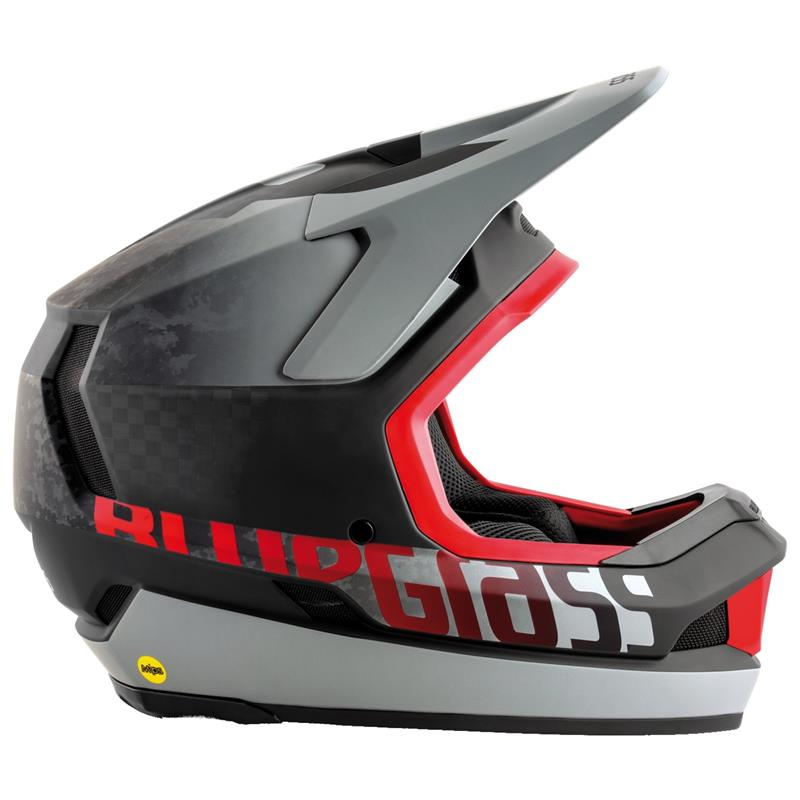Considering the design and features of this helmet, what specific safety standards or certifications does the yellow sticker on the lower left side of the helmet represent, and why might this be important for a user? The yellow sticker on the lower left side of the helmet likely represents a specific safety certification, which is crucial for ensuring the helmet's reliability and protective performance. Although the exact certification cannot be identified from the image alone, similar stickers often indicate compliance with recognized safety standards like DOT (Department of Transportation), SNELL, or ECE (Economic Commission for Europe). Such certifications are critical because they assure the user that the helmet has undergone rigorous testing for aspects like impact absorption, penetration resistance, strap system effectiveness, and field of vision. These factors are essential for enhancing the safety of the wearer, reducing the risk of severe injury during an accident. 